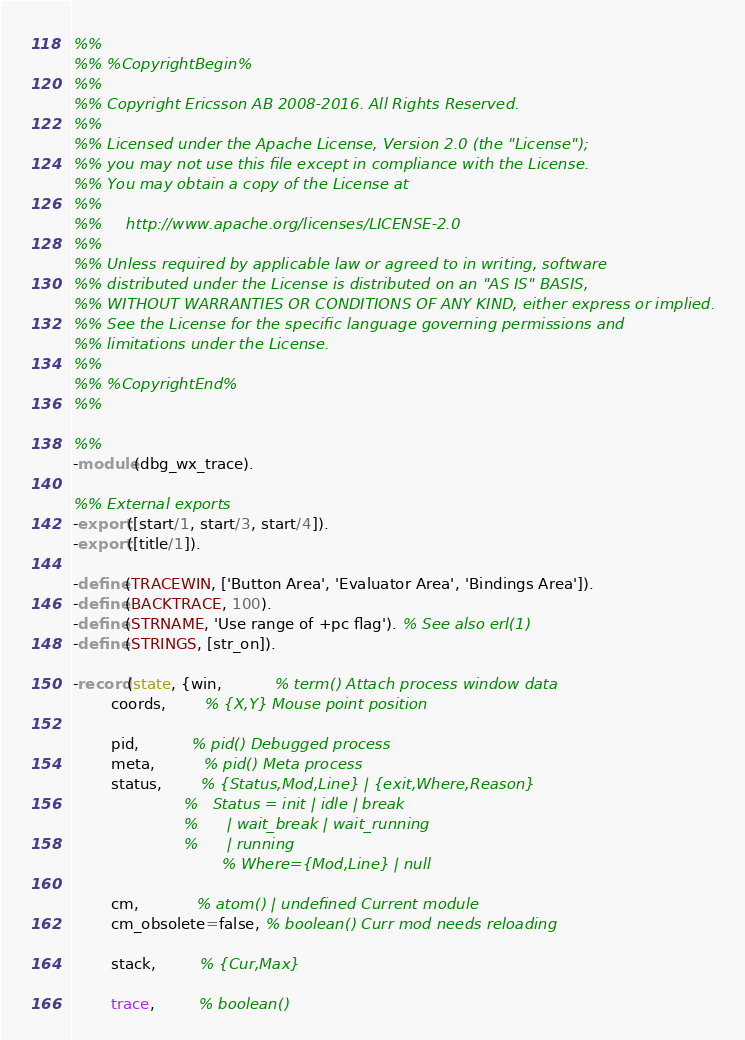<code> <loc_0><loc_0><loc_500><loc_500><_Erlang_>%%
%% %CopyrightBegin%
%% 
%% Copyright Ericsson AB 2008-2016. All Rights Reserved.
%% 
%% Licensed under the Apache License, Version 2.0 (the "License");
%% you may not use this file except in compliance with the License.
%% You may obtain a copy of the License at
%%
%%     http://www.apache.org/licenses/LICENSE-2.0
%%
%% Unless required by applicable law or agreed to in writing, software
%% distributed under the License is distributed on an "AS IS" BASIS,
%% WITHOUT WARRANTIES OR CONDITIONS OF ANY KIND, either express or implied.
%% See the License for the specific language governing permissions and
%% limitations under the License.
%% 
%% %CopyrightEnd%
%%

%%
-module(dbg_wx_trace).

%% External exports
-export([start/1, start/3, start/4]).
-export([title/1]).

-define(TRACEWIN, ['Button Area', 'Evaluator Area', 'Bindings Area']).
-define(BACKTRACE, 100).
-define(STRNAME, 'Use range of +pc flag'). % See also erl(1)
-define(STRINGS, [str_on]).

-record(state, {win,           % term() Attach process window data
		coords,        % {X,Y} Mouse point position

		pid,           % pid() Debugged process
		meta,          % pid() Meta process
		status,        % {Status,Mod,Line} | {exit,Where,Reason}
		               %   Status = init | idle | break
		               %      | wait_break | wait_running
		               %      | running
                               % Where={Mod,Line} | null

		cm,            % atom() | undefined Current module
		cm_obsolete=false, % boolean() Curr mod needs reloading

		stack,         % {Cur,Max}

		trace,         % boolean()</code> 